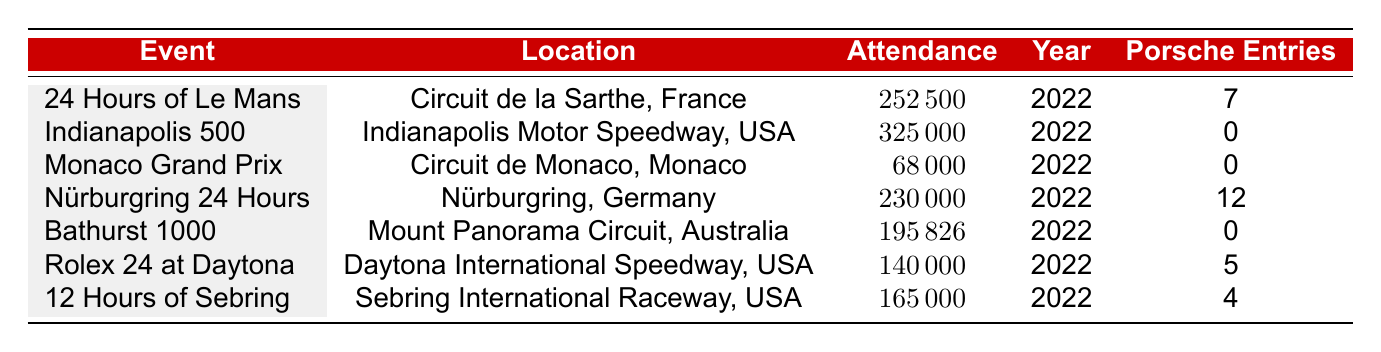What is the total attendance for the 24 Hours of Le Mans? The attendance for the 24 Hours of Le Mans in 2022 is listed in the table as 252500.
Answer: 252500 Which event had the highest attendance in 2022? By comparing the attendance figures in the table, the Indianapolis 500 has the highest attendance at 325000.
Answer: Indianapolis 500 How many Porsche entries were recorded for the Nürburgring 24 Hours? The number of Porsche entries for the Nürburgring 24 Hours in 2022 is given as 12 in the table.
Answer: 12 What is the average attendance of events with Porsche entries in 2022? The events with Porsche entries are the 24 Hours of Le Mans (attendance 252500), Nürburgring 24 Hours (230000), Rolex 24 at Daytona (140000), and 12 Hours of Sebring (165000). The total attendance is 252500 + 230000 + 140000 + 165000 = 787500. There are 4 events, so the average is 787500 / 4 = 196875.
Answer: 196875 Did the Monaco Grand Prix have any Porsche entries in 2022? The table indicates that the Monaco Grand Prix had 0 Porsche entries in 2022.
Answer: No What is the difference in attendance between the Indianapolis 500 and the Bathurst 1000? The attendance for the Indianapolis 500 is 325000 and for the Bathurst 1000 is 195826. The difference is 325000 - 195826 = 129174.
Answer: 129174 Which events had an attendance of over 200000 in 2022? By reviewing the attendance figures, the events with over 200000 attendees are the Indianapolis 500 (325000) and the 24 Hours of Le Mans (252500).
Answer: Indianapolis 500, 24 Hours of Le Mans How many total Porsche entries are there across all events listed in the table? The total number of Porsche entries can be calculated by summing the individual entries: 7 (Le Mans) + 0 (Indianapolis 500) + 0 (Monaco GP) + 12 (Nürburgring) + 0 (Bathurst 1000) + 5 (Rolex 24) + 4 (Sebring) = 28.
Answer: 28 Was the attendance for the Nürburgring 24 Hours greater than the Rolex 24 at Daytona? The attendance for the Nürburgring 24 Hours is 230000 while the Rolex 24 at Daytona is 140000. Since 230000 is greater than 140000, the statement is true.
Answer: Yes 